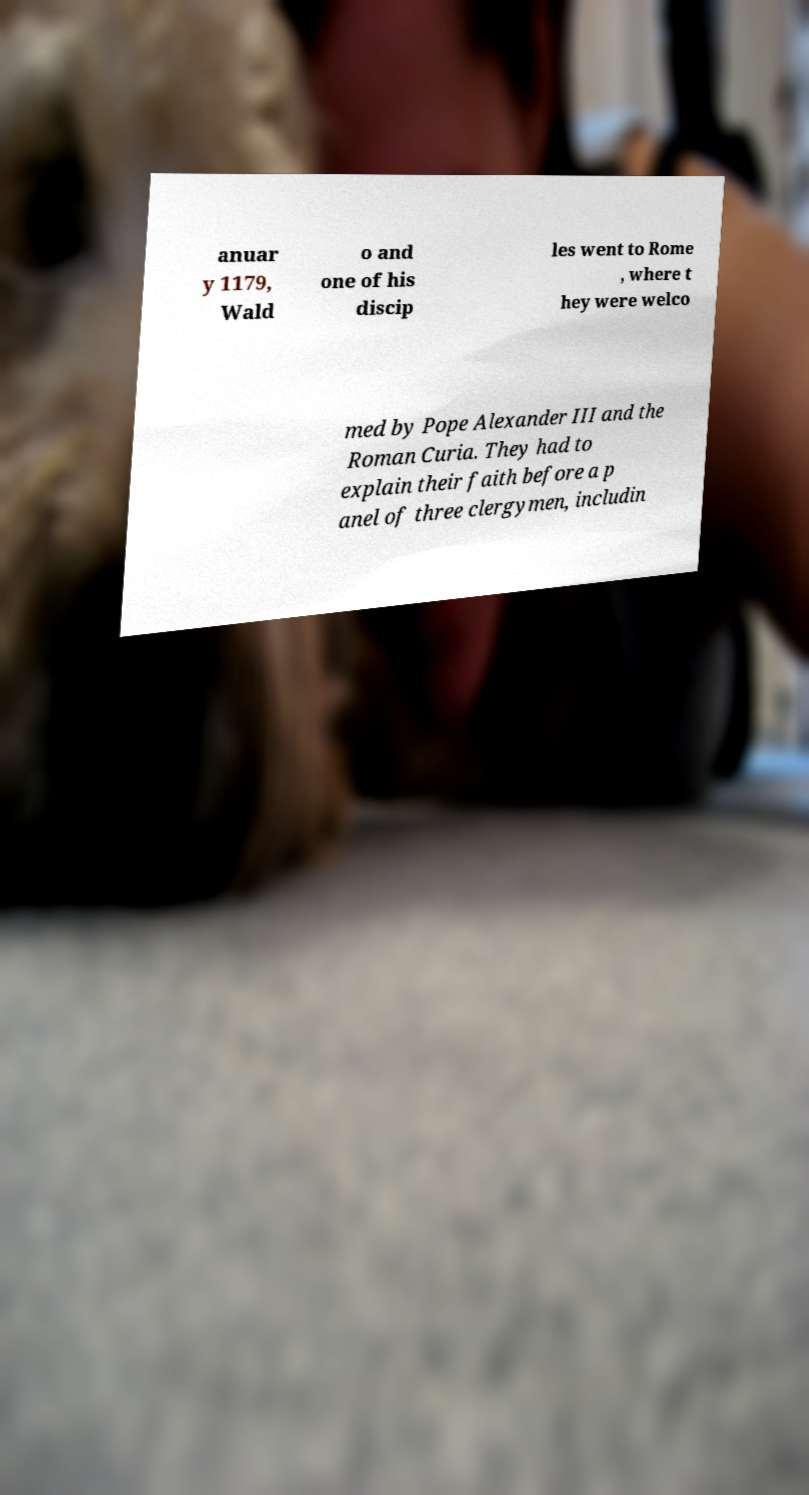I need the written content from this picture converted into text. Can you do that? anuar y 1179, Wald o and one of his discip les went to Rome , where t hey were welco med by Pope Alexander III and the Roman Curia. They had to explain their faith before a p anel of three clergymen, includin 